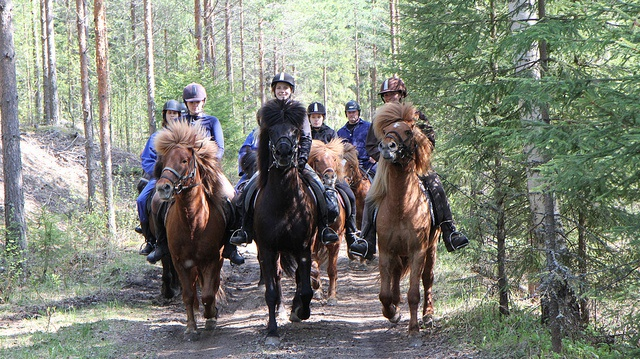Describe the objects in this image and their specific colors. I can see horse in gray, black, and maroon tones, horse in gray and black tones, horse in gray, black, and maroon tones, people in gray, black, and darkgray tones, and people in gray, black, and darkgray tones in this image. 